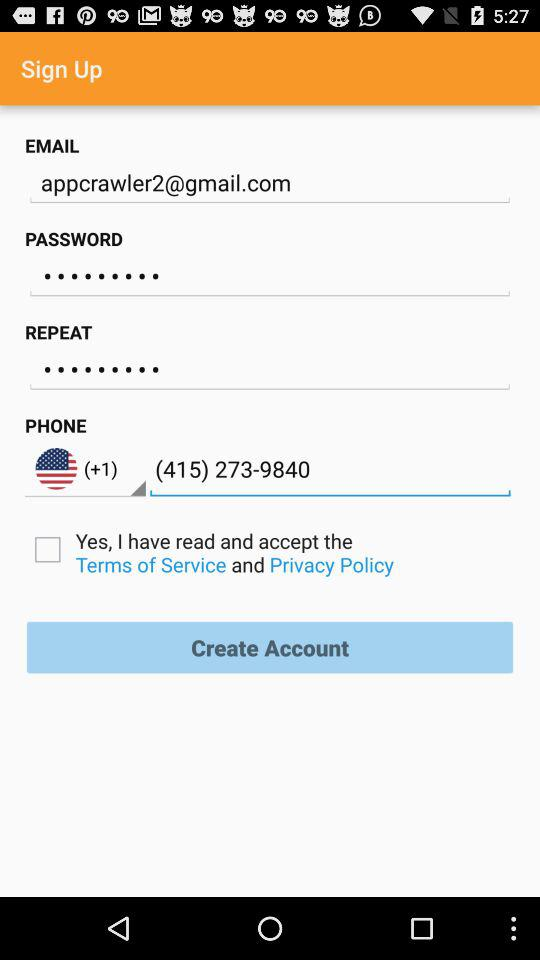What is the email address? The email address is appcrawler2@gmail.com. 